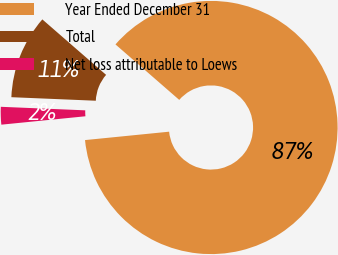Convert chart to OTSL. <chart><loc_0><loc_0><loc_500><loc_500><pie_chart><fcel>Year Ended December 31<fcel>Total<fcel>Net loss attributable to Loews<nl><fcel>87.03%<fcel>10.73%<fcel>2.25%<nl></chart> 